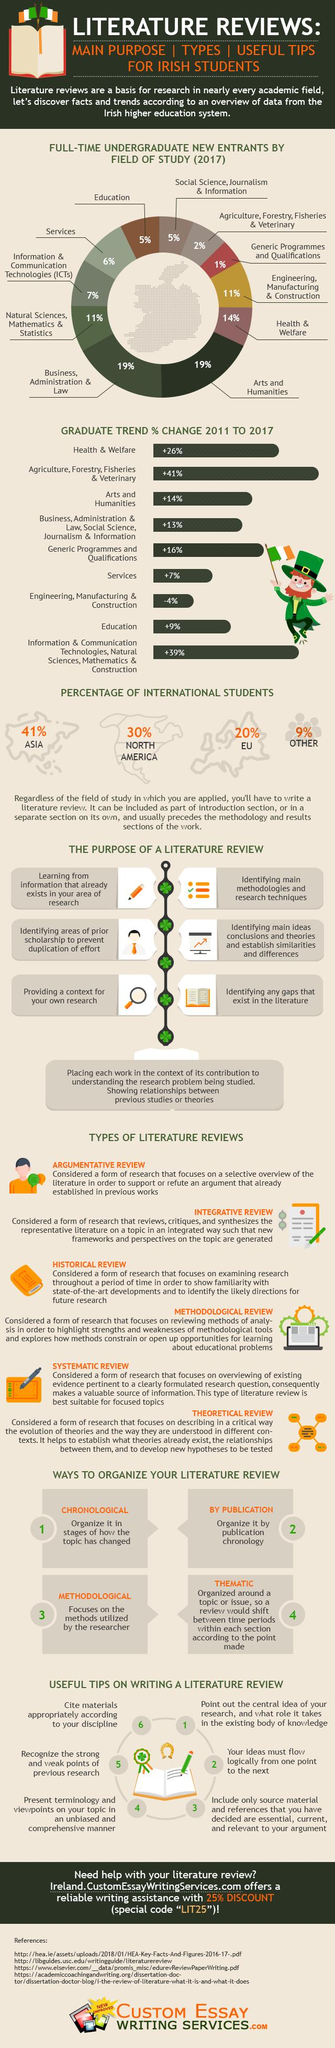List a handful of essential elements in this visual. In 2021, the percentage of education and services taken together was found to be 11%. There are six types of literature reviews. According to a recent survey, 30% of North American students reportedly possess the ability to communicate with extraterrestrial beings. The combined percentage of services and health and welfare is 33%. 